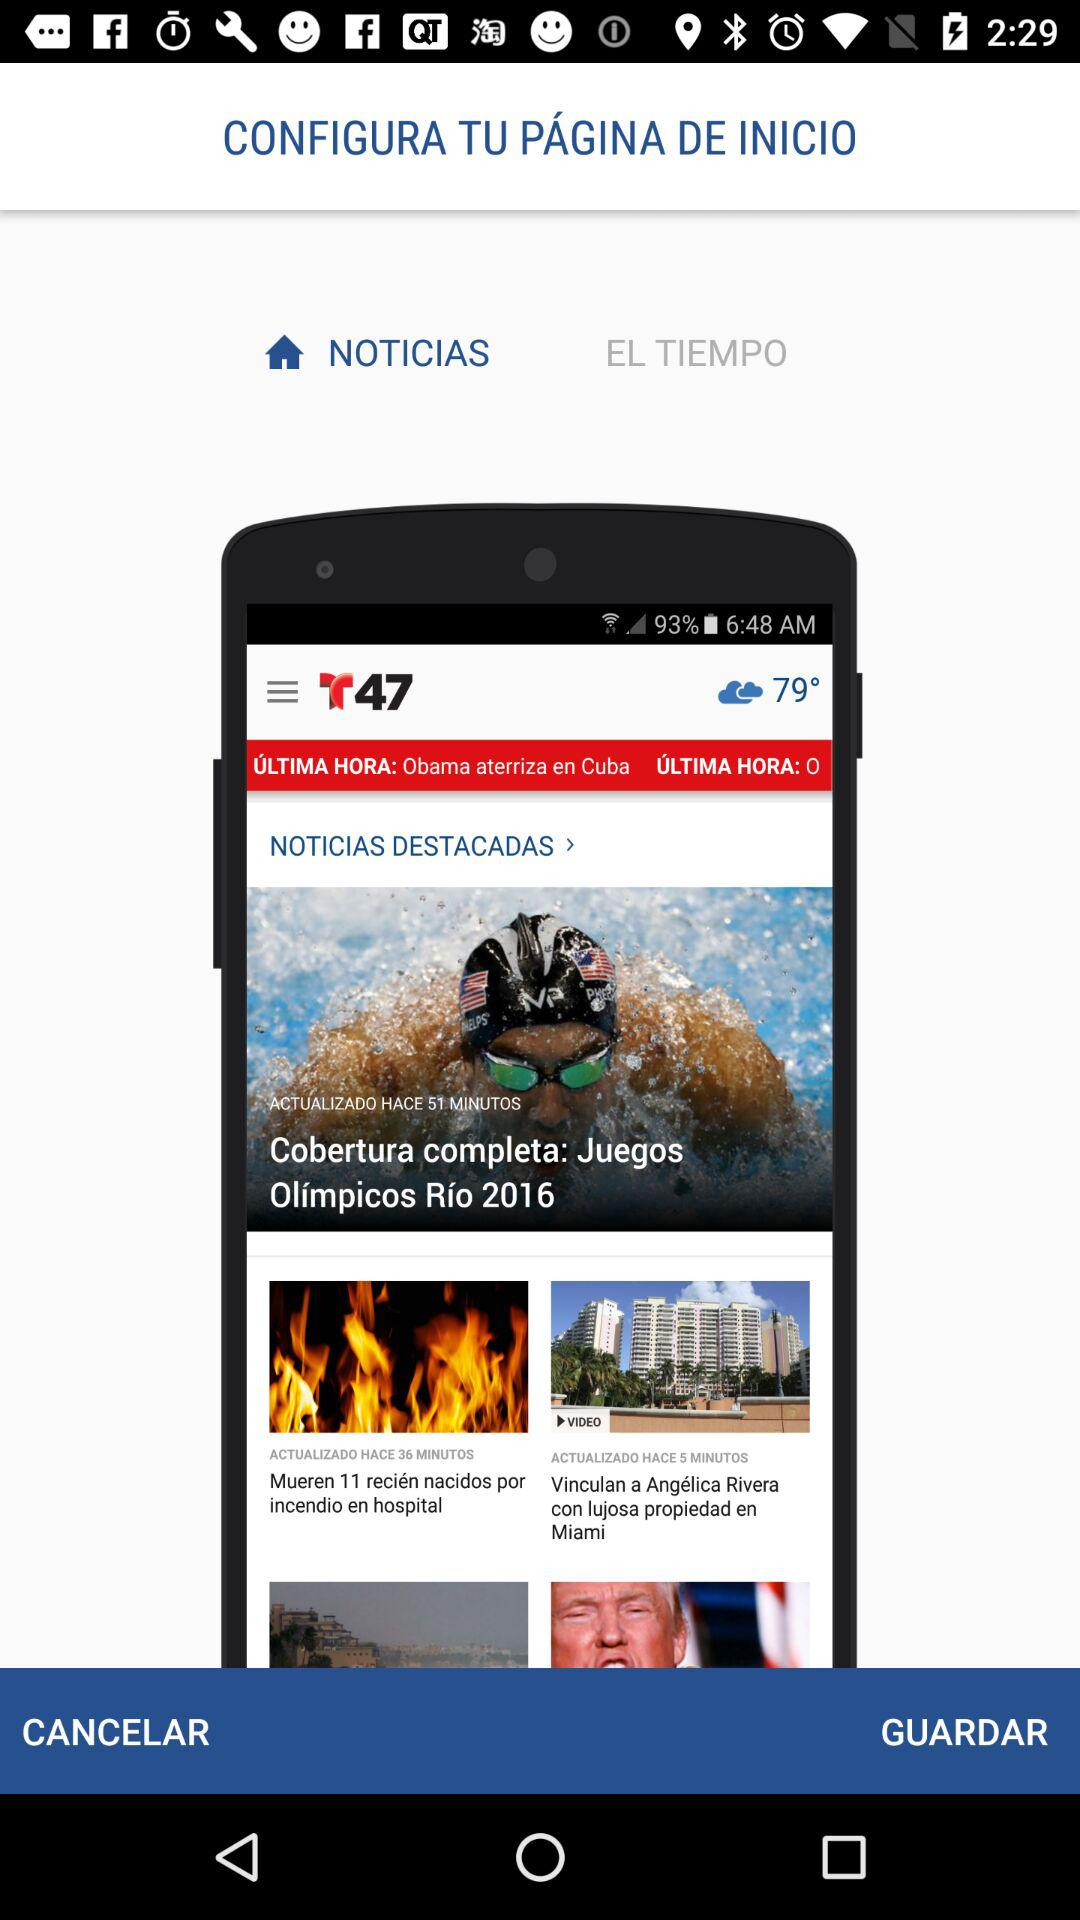Which tab has been selected? The selected tab is "Noticias". 